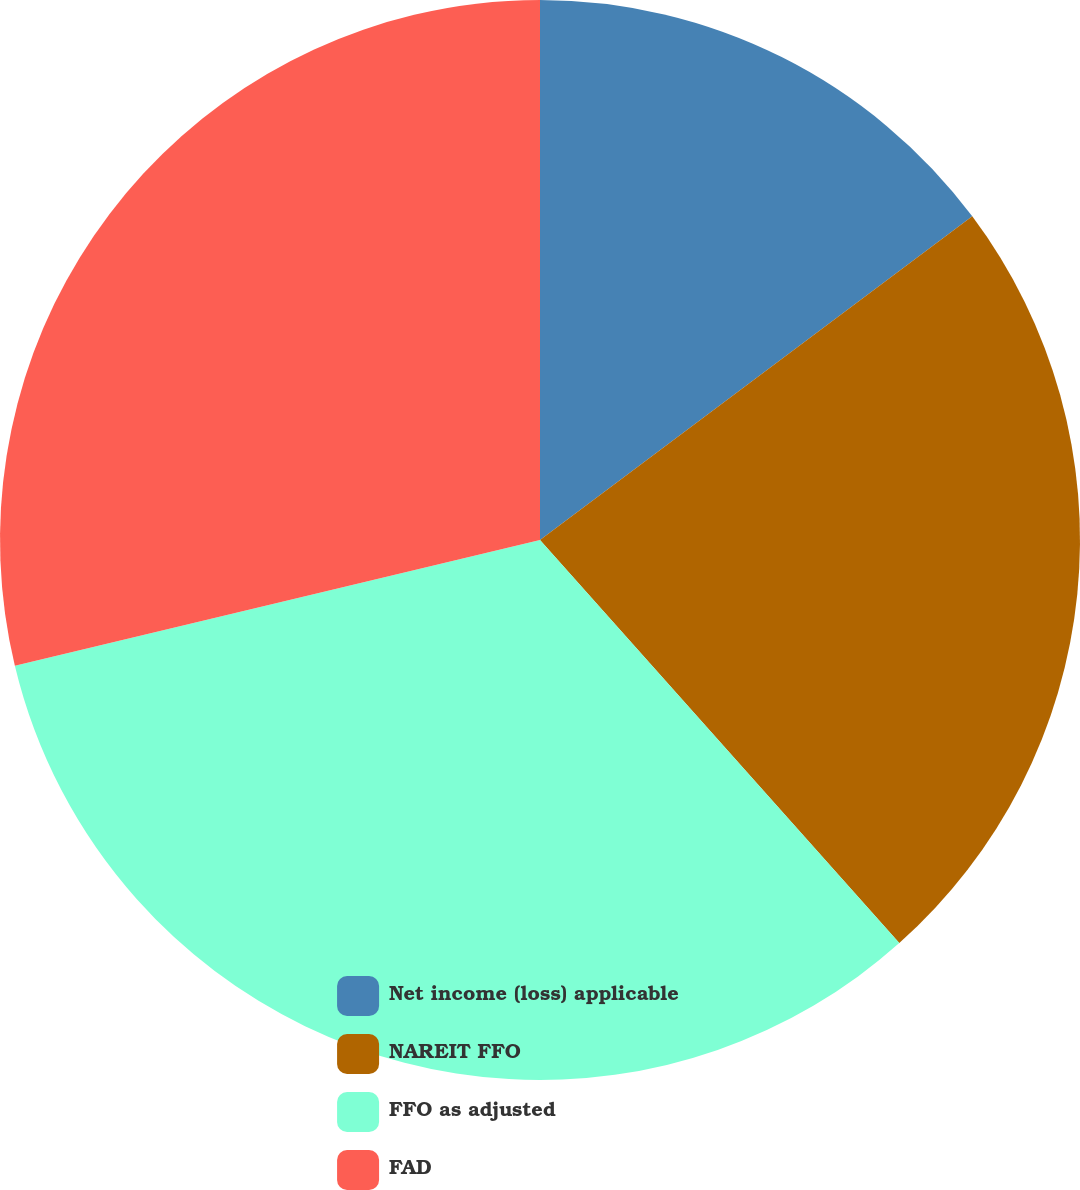Convert chart. <chart><loc_0><loc_0><loc_500><loc_500><pie_chart><fcel>Net income (loss) applicable<fcel>NAREIT FFO<fcel>FFO as adjusted<fcel>FAD<nl><fcel>14.77%<fcel>23.64%<fcel>32.84%<fcel>28.74%<nl></chart> 